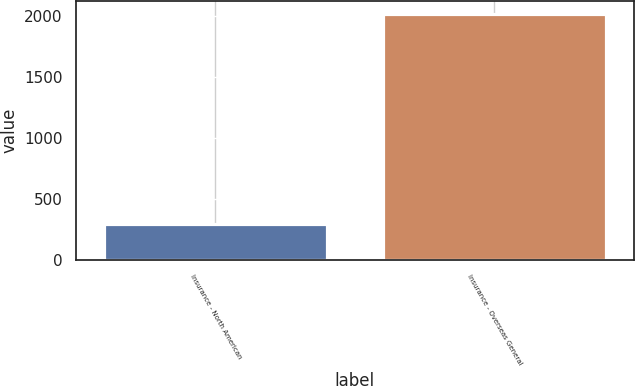Convert chart. <chart><loc_0><loc_0><loc_500><loc_500><bar_chart><fcel>Insurance - North American<fcel>Insurance - Overseas General<nl><fcel>296<fcel>2016<nl></chart> 